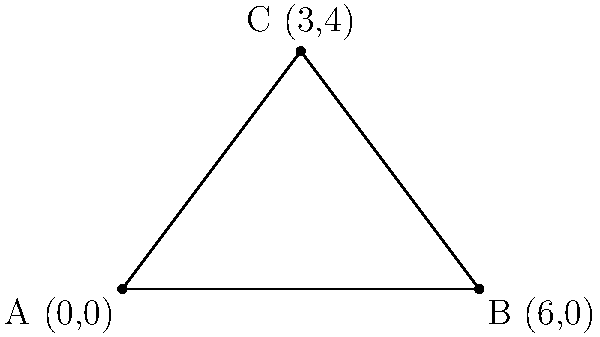You're considering purchasing a triangular plot of land in Bigler, PA. The realtor provides you with a coordinate map of the property. The vertices of the triangular plot are located at A(0,0), B(6,0), and C(3,4). Using your knowledge of coordinate geometry, calculate the area of this triangular plot. Express your answer in square units. To find the area of a triangle given the coordinates of its vertices, we can use the formula:

$$\text{Area} = \frac{1}{2}|x_1(y_2 - y_3) + x_2(y_3 - y_1) + x_3(y_1 - y_2)|$$

Where $(x_1, y_1)$, $(x_2, y_2)$, and $(x_3, y_3)$ are the coordinates of the three vertices.

Let's substitute the given coordinates:
A(0,0), B(6,0), and C(3,4)

$(x_1, y_1) = (0, 0)$
$(x_2, y_2) = (6, 0)$
$(x_3, y_3) = (3, 4)$

Now, let's calculate:

$$\begin{align*}
\text{Area} &= \frac{1}{2}|0(0 - 4) + 6(4 - 0) + 3(0 - 0)| \\
&= \frac{1}{2}|0 + 24 + 0| \\
&= \frac{1}{2}(24) \\
&= 12
\end{align*}$$

Therefore, the area of the triangular plot is 12 square units.
Answer: 12 square units 